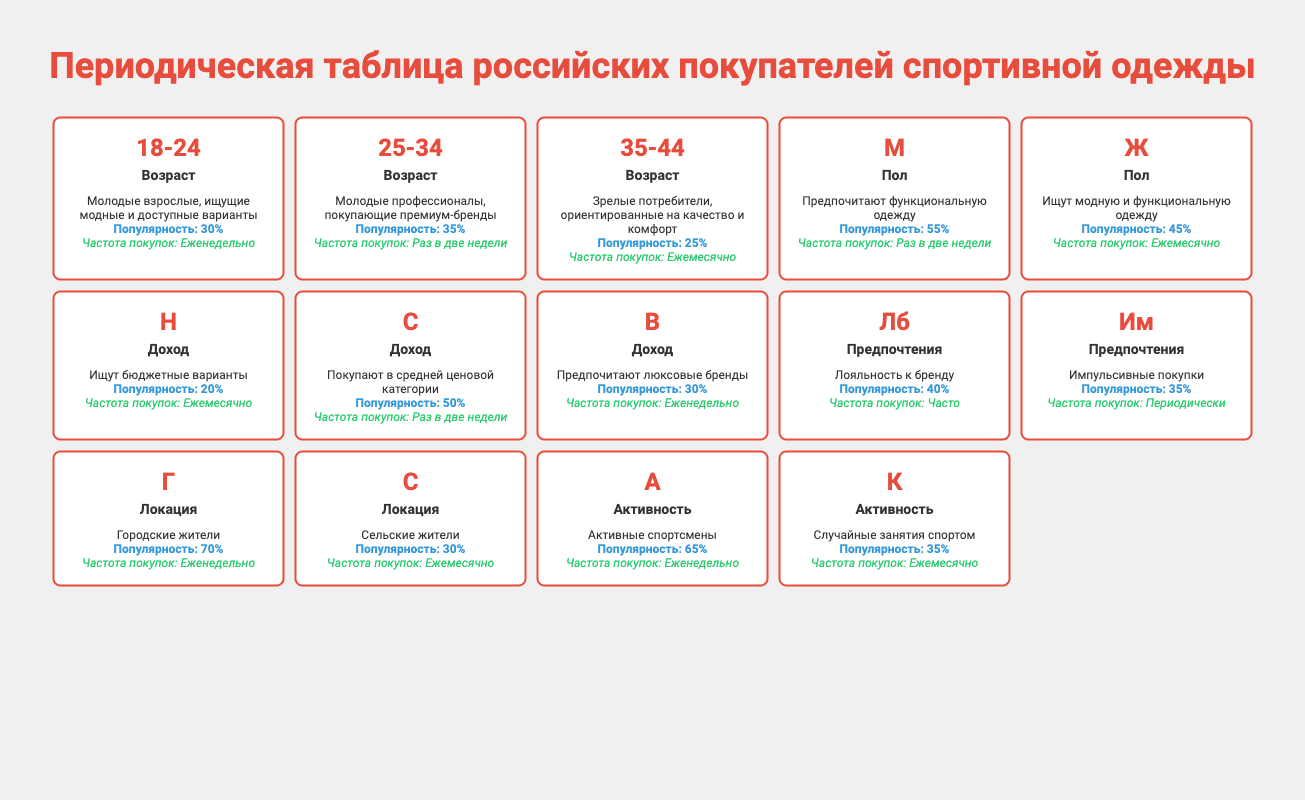What is the most popular age group among sports apparel shoppers in Russia? The most popular age group can be found by looking for the highest popularity percentage in the Age Group category. The 25-34 age group has a popularity of 35%, which is higher than the 18-24 (30%) and 35-44 (25%) age groups.
Answer: 25-34 Which gender has a higher purchase frequency for sports apparel? The purchase frequency can be found in the Gender category. Males have a purchase frequency of "Bi-weekly" while females have "Monthly." In terms of frequency, Bi-weekly implies higher purchase activity than Monthly, indicating males purchase more frequently.
Answer: Male What is the total popularity percentage of low and middle-income sports apparel shoppers? To find the total popularity percentage, we sum the popularity values of Low Income (20%) and Middle Income (50%). The total is 20% + 50% = 70%.
Answer: 70% Are urban shoppers more likely to buy sports apparel than rural shoppers? We compare the popularity percentages for Urban (70%) and Rural (30%) shoppers. Since 70% is greater than 30%, urban shoppers are indeed more likely to buy sports apparel than rural shoppers.
Answer: Yes Which group of sports apparel shoppers participates more in regular exercise, the active or casual group? We compare the popularity percentages. The Active (Regular Exercise) group has a popularity of 65%, while the Casual (Occasional Exercise) group has 35%. Since 65% is greater, the Active group participates more in regular exercise.
Answer: Active (Regular Exercise) What percentage of female shoppers engage in impulsive shopping? To find this, look for the impulsive shopping percentage specifically in the Female category. That information is not provided directly but is indicated that impulsive shopping is 35%, which applies to all shoppers regardless of gender. Therefore, the exact percentage of female shoppers engaging in impulsive shopping isn't specified in the data.
Answer: Not specified What is the average popularity percentage for shoppers based on age groups only? We have three age groups with their respective popularity percentages: 30% (18-24), 35% (25-34), and 25% (35-44). The average is calculated by summing these percentages (30 + 35 + 25 = 90) and dividing by the number of age groups (3): 90/3 = 30%.
Answer: 30% Do shoppers with brand loyalty purchase more frequently than those who shop impulsively? Brand loyalty has a purchase frequency of "Frequent," while impulsive shopping has "Occasional." Frequent indicates a higher purchase frequency than Occasional, suggesting brand-loyal shoppers buy more often.
Answer: Yes Is there a notable difference in popularity between male shoppers (55%) and female shoppers (45%)? The difference in popularity can be calculated by subtracting female popularity from male popularity: 55% - 45% = 10%. Since there is a 10% difference, we can conclude that male shoppers are notably more popular than female shoppers.
Answer: Yes 